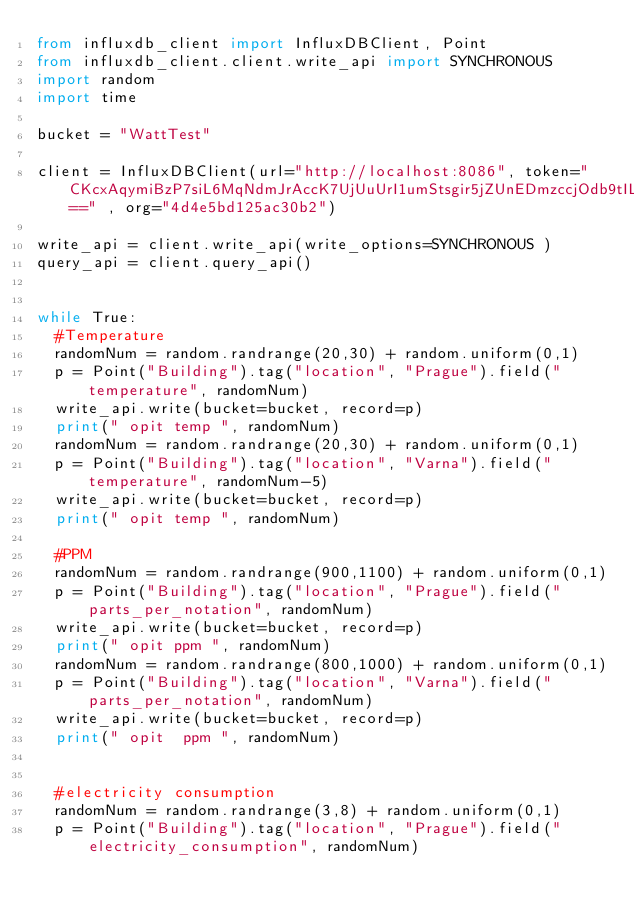Convert code to text. <code><loc_0><loc_0><loc_500><loc_500><_Python_>from influxdb_client import InfluxDBClient, Point
from influxdb_client.client.write_api import SYNCHRONOUS
import random
import time

bucket = "WattTest"

client = InfluxDBClient(url="http://localhost:8086", token="CKcxAqymiBzP7siL6MqNdmJrAccK7UjUuUrI1umStsgir5jZUnEDmzccjOdb9tILNvqA3GDp_dK_OeTf6QkUcQ==" , org="4d4e5bd125ac30b2")

write_api = client.write_api(write_options=SYNCHRONOUS )
query_api = client.query_api()


while True:
  #Temperature
  randomNum = random.randrange(20,30) + random.uniform(0,1)
  p = Point("Building").tag("location", "Prague").field("temperature", randomNum)
  write_api.write(bucket=bucket, record=p)
  print(" opit temp ", randomNum)
  randomNum = random.randrange(20,30) + random.uniform(0,1)
  p = Point("Building").tag("location", "Varna").field("temperature", randomNum-5)
  write_api.write(bucket=bucket, record=p)
  print(" opit temp ", randomNum)
  
  #PPM
  randomNum = random.randrange(900,1100) + random.uniform(0,1)
  p = Point("Building").tag("location", "Prague").field("parts_per_notation", randomNum)
  write_api.write(bucket=bucket, record=p)
  print(" opit ppm ", randomNum)
  randomNum = random.randrange(800,1000) + random.uniform(0,1)
  p = Point("Building").tag("location", "Varna").field("parts_per_notation", randomNum)
  write_api.write(bucket=bucket, record=p)
  print(" opit  ppm ", randomNum)
  

  #electricity consumption
  randomNum = random.randrange(3,8) + random.uniform(0,1)
  p = Point("Building").tag("location", "Prague").field("electricity_consumption", randomNum)</code> 